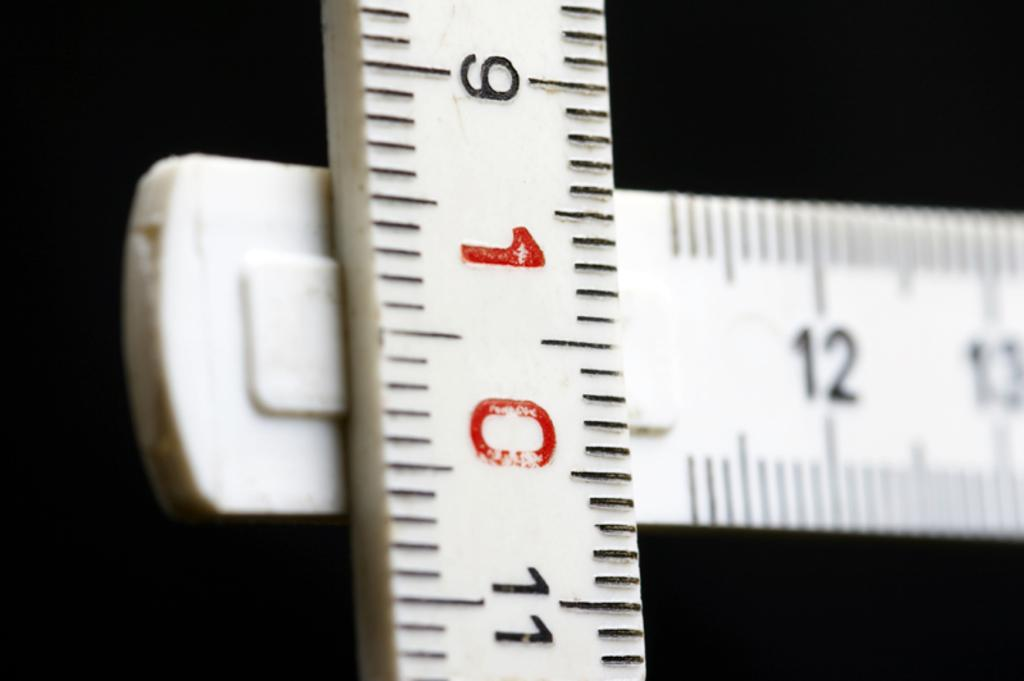<image>
Provide a brief description of the given image. Two perpendicular rulers, the vertical one has the number 10 in red. 